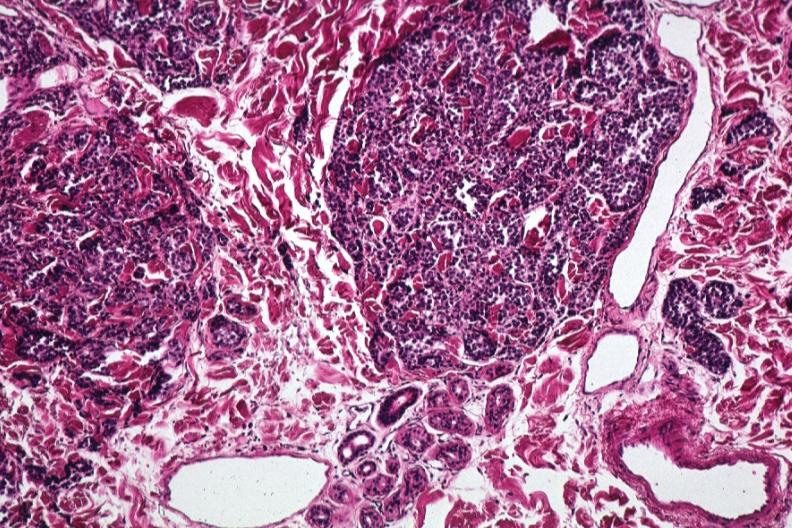what does this image show?
Answer the question using a single word or phrase. Med lesion extension to sweat glands same as 2 